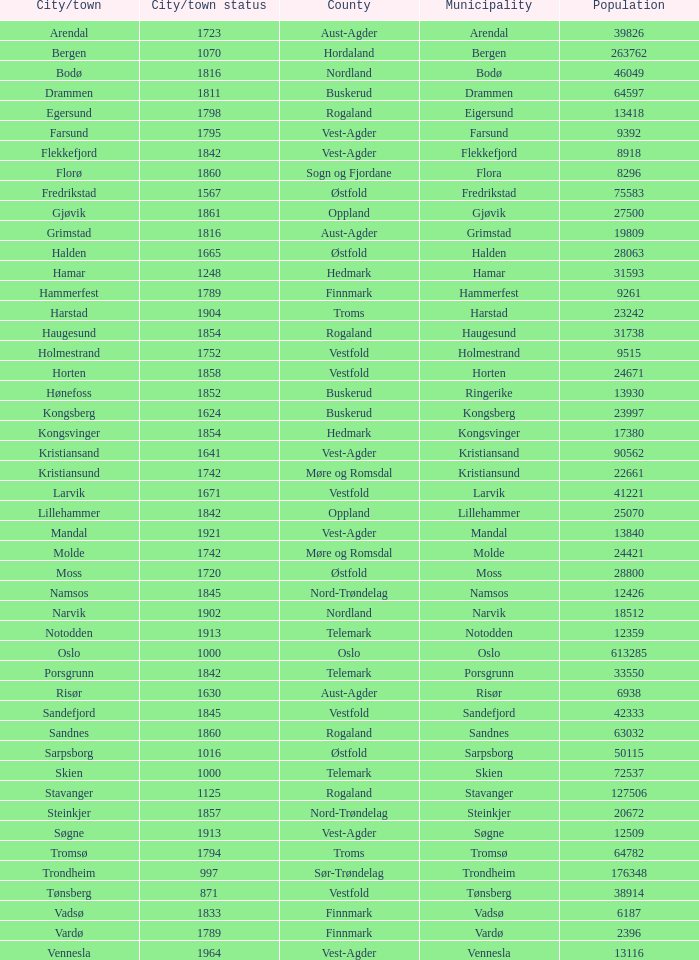Which municipality has a population of 24421? Molde. Write the full table. {'header': ['City/town', 'City/town status', 'County', 'Municipality', 'Population'], 'rows': [['Arendal', '1723', 'Aust-Agder', 'Arendal', '39826'], ['Bergen', '1070', 'Hordaland', 'Bergen', '263762'], ['Bodø', '1816', 'Nordland', 'Bodø', '46049'], ['Drammen', '1811', 'Buskerud', 'Drammen', '64597'], ['Egersund', '1798', 'Rogaland', 'Eigersund', '13418'], ['Farsund', '1795', 'Vest-Agder', 'Farsund', '9392'], ['Flekkefjord', '1842', 'Vest-Agder', 'Flekkefjord', '8918'], ['Florø', '1860', 'Sogn og Fjordane', 'Flora', '8296'], ['Fredrikstad', '1567', 'Østfold', 'Fredrikstad', '75583'], ['Gjøvik', '1861', 'Oppland', 'Gjøvik', '27500'], ['Grimstad', '1816', 'Aust-Agder', 'Grimstad', '19809'], ['Halden', '1665', 'Østfold', 'Halden', '28063'], ['Hamar', '1248', 'Hedmark', 'Hamar', '31593'], ['Hammerfest', '1789', 'Finnmark', 'Hammerfest', '9261'], ['Harstad', '1904', 'Troms', 'Harstad', '23242'], ['Haugesund', '1854', 'Rogaland', 'Haugesund', '31738'], ['Holmestrand', '1752', 'Vestfold', 'Holmestrand', '9515'], ['Horten', '1858', 'Vestfold', 'Horten', '24671'], ['Hønefoss', '1852', 'Buskerud', 'Ringerike', '13930'], ['Kongsberg', '1624', 'Buskerud', 'Kongsberg', '23997'], ['Kongsvinger', '1854', 'Hedmark', 'Kongsvinger', '17380'], ['Kristiansand', '1641', 'Vest-Agder', 'Kristiansand', '90562'], ['Kristiansund', '1742', 'Møre og Romsdal', 'Kristiansund', '22661'], ['Larvik', '1671', 'Vestfold', 'Larvik', '41221'], ['Lillehammer', '1842', 'Oppland', 'Lillehammer', '25070'], ['Mandal', '1921', 'Vest-Agder', 'Mandal', '13840'], ['Molde', '1742', 'Møre og Romsdal', 'Molde', '24421'], ['Moss', '1720', 'Østfold', 'Moss', '28800'], ['Namsos', '1845', 'Nord-Trøndelag', 'Namsos', '12426'], ['Narvik', '1902', 'Nordland', 'Narvik', '18512'], ['Notodden', '1913', 'Telemark', 'Notodden', '12359'], ['Oslo', '1000', 'Oslo', 'Oslo', '613285'], ['Porsgrunn', '1842', 'Telemark', 'Porsgrunn', '33550'], ['Risør', '1630', 'Aust-Agder', 'Risør', '6938'], ['Sandefjord', '1845', 'Vestfold', 'Sandefjord', '42333'], ['Sandnes', '1860', 'Rogaland', 'Sandnes', '63032'], ['Sarpsborg', '1016', 'Østfold', 'Sarpsborg', '50115'], ['Skien', '1000', 'Telemark', 'Skien', '72537'], ['Stavanger', '1125', 'Rogaland', 'Stavanger', '127506'], ['Steinkjer', '1857', 'Nord-Trøndelag', 'Steinkjer', '20672'], ['Søgne', '1913', 'Vest-Agder', 'Søgne', '12509'], ['Tromsø', '1794', 'Troms', 'Tromsø', '64782'], ['Trondheim', '997', 'Sør-Trøndelag', 'Trondheim', '176348'], ['Tønsberg', '871', 'Vestfold', 'Tønsberg', '38914'], ['Vadsø', '1833', 'Finnmark', 'Vadsø', '6187'], ['Vardø', '1789', 'Finnmark', 'Vardø', '2396'], ['Vennesla', '1964', 'Vest-Agder', 'Vennesla', '13116']]} 